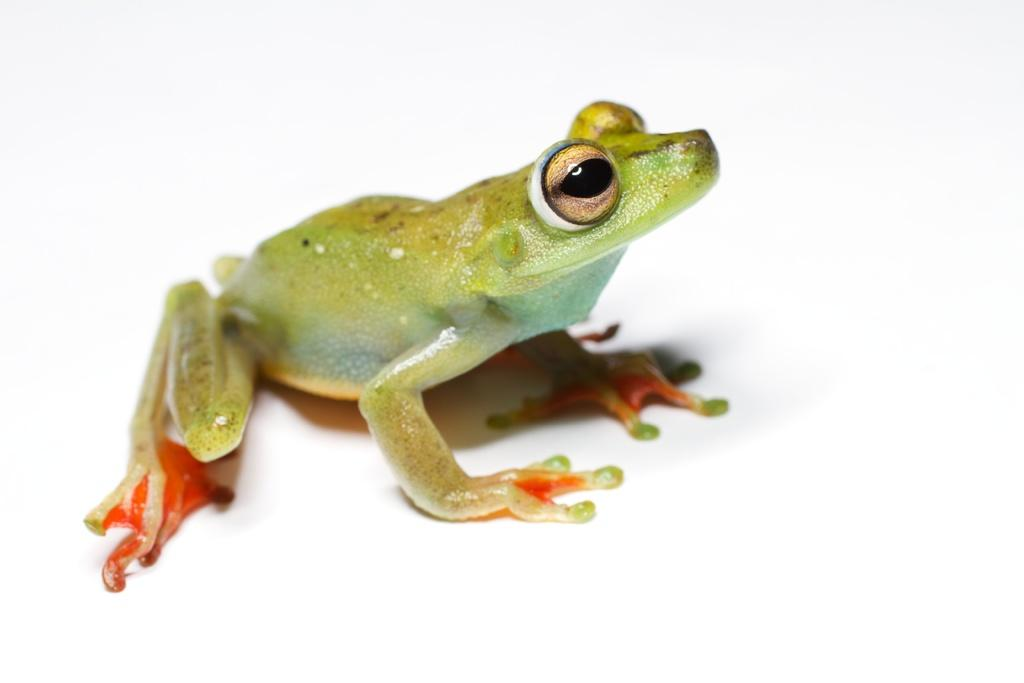What type of animal is in the picture? There is a green frog frog in the picture. What is the frog standing on? The frog is standing on a white object. What color is on the frog's hands and legs? The frog has red color on its hands and legs. Is the frog sleeping in the picture? No, the frog is not sleeping in the picture; it is standing on a white object with its hands and legs showing red color. 